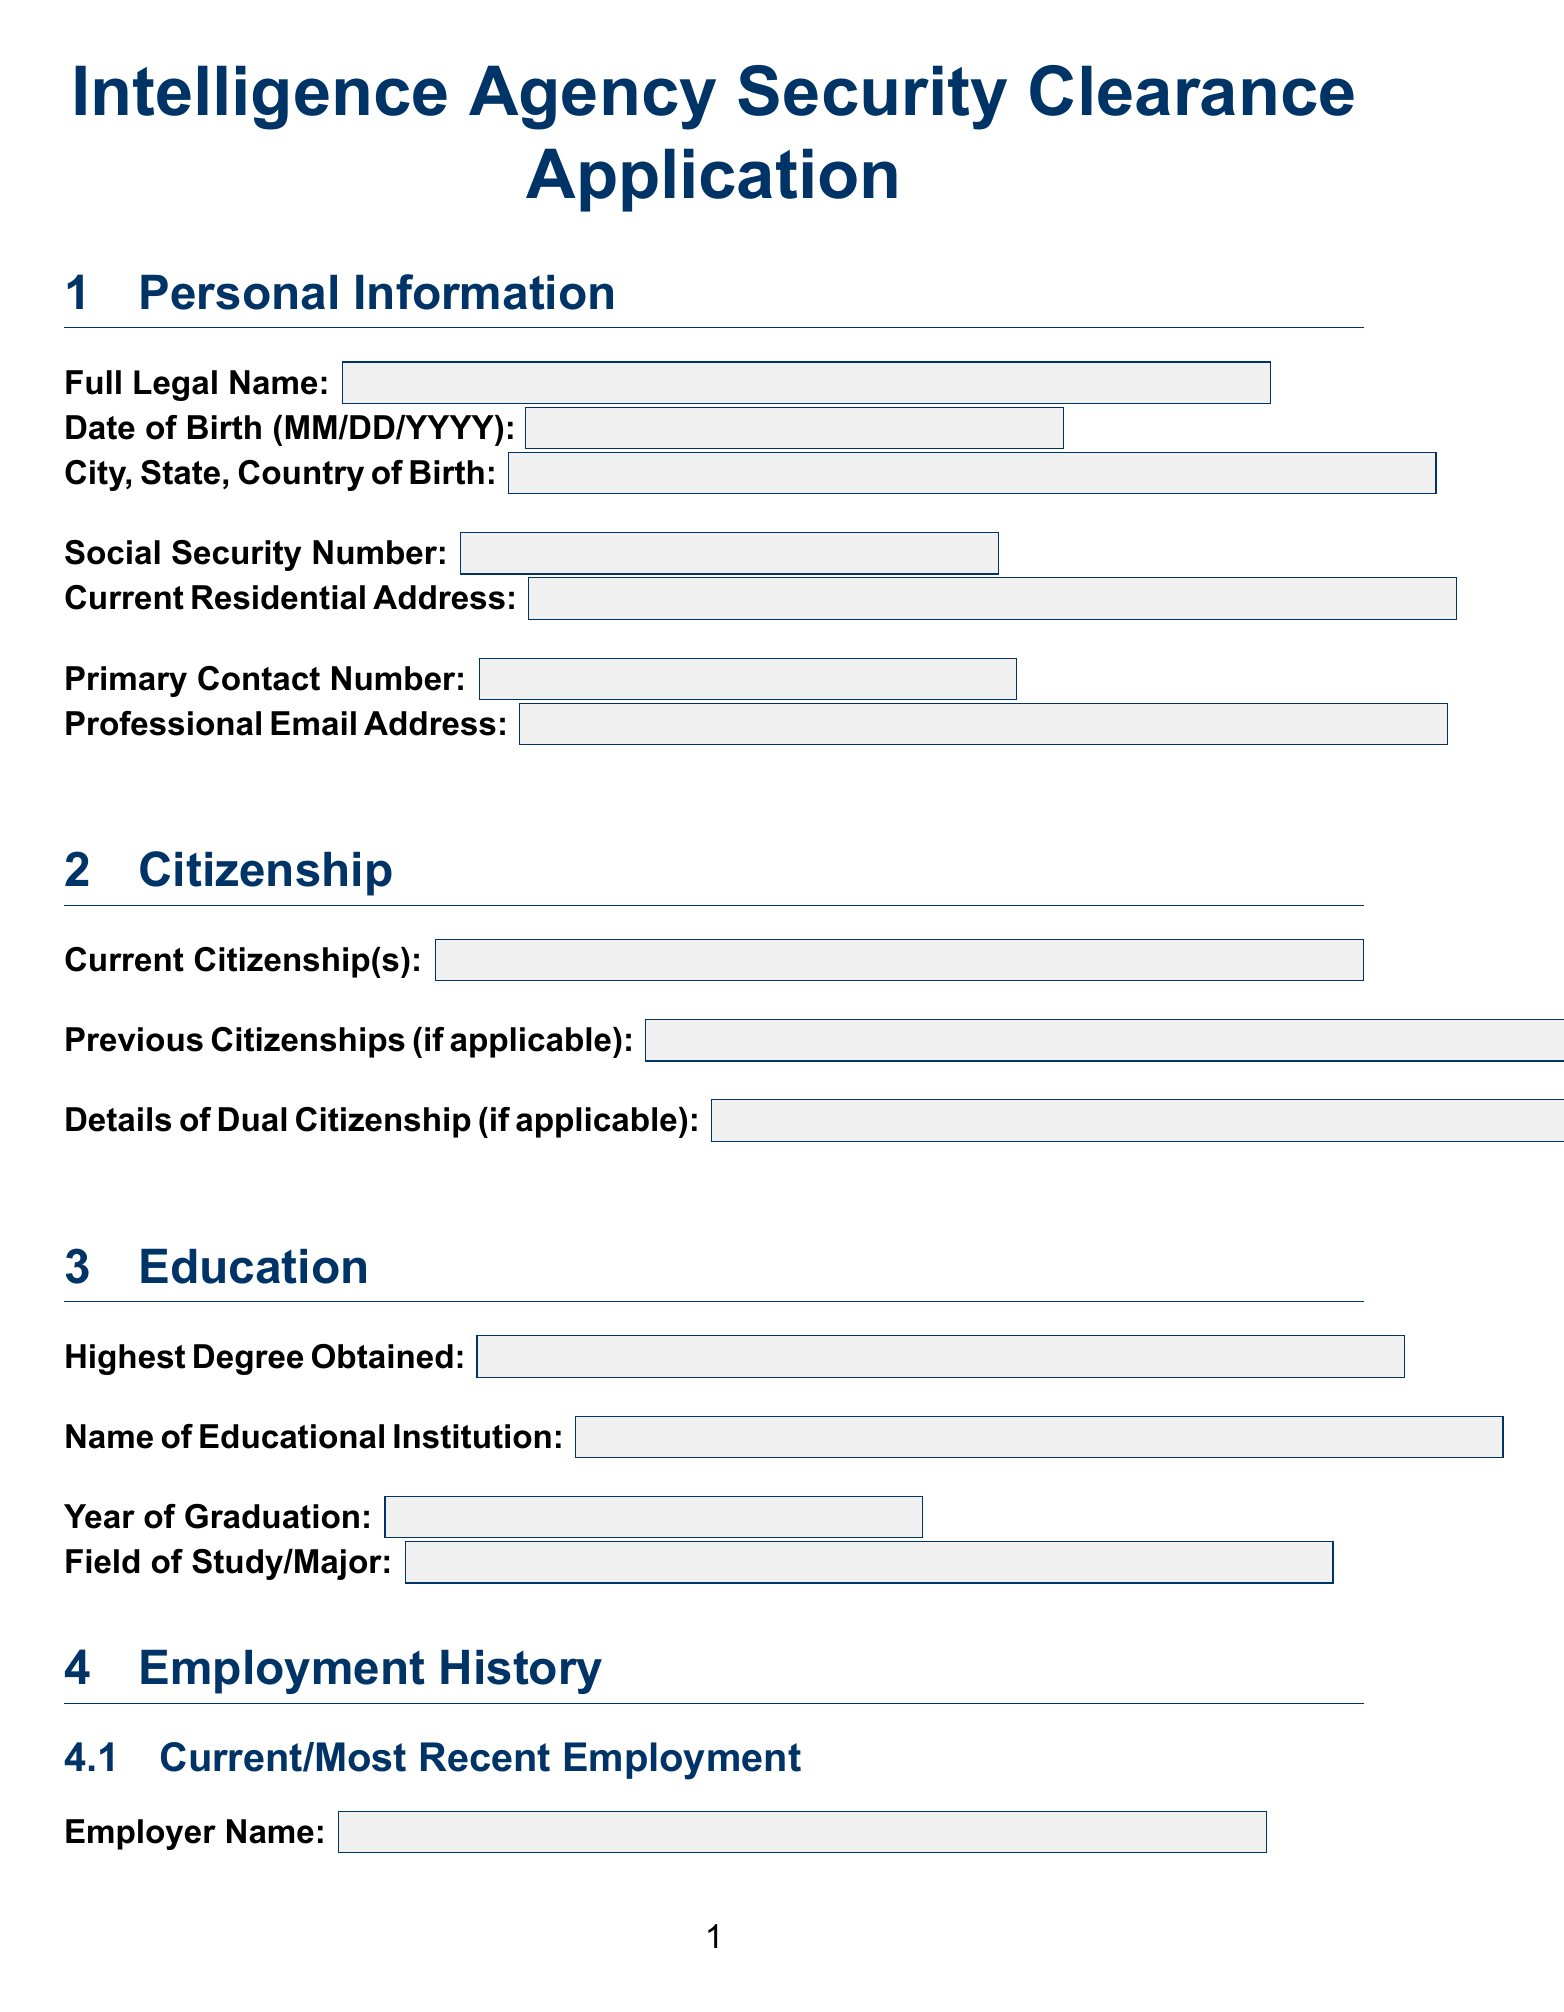What is the full legal name required on the application? The document specifies that the applicant needs to provide their full legal name in the personal information section.
Answer: Full Legal Name When was the date of birth expected to be provided? The date of birth is requested in the format MM/DD/YYYY in the personal information section of the form.
Answer: MM/DD/YYYY What is the highest degree obtained by the applicant? The document includes a section that asks for the highest degree obtained, indicating educational qualifications.
Answer: Highest Degree Obtained Who is the immediate supervisor for the current employer? The form requests the name of the immediate supervisor associated with the applicant's current employment.
Answer: Immediate Supervisor's Name List the training specific to professional background mentioned in the document. The document specifies different specialized training relevant to the applicant's professional background, which helps gauge preparedness.
Answer: Hostile Environment Awareness Training (HEAT), Digital Security for Journalists, Advanced Open-Source Intelligence (OSINT) Techniques How many languages should the applicant indicate proficiency in? The document prompts applicants to list the languages they speak along with the corresponding proficiency level, highlighting diversity in communication skills.
Answer: Language Name Does the applicant have any ongoing investigations related to government agencies? The document includes a security question that inquires about ongoing investigations involving government agencies or political figures, crucial for background checks.
Answer: Yes or No What is the consent given by the applicant for the background check? There is a declaration section that clarifies the applicant's consent to undergo a comprehensive background check as part of the security clearance process.
Answer: I consent to a comprehensive background check What are the references required in the document? The document includes a references section where the applicant must provide a full name, relationship, and contact information for their references.
Answer: Reference Full Name, Professional Relationship, Phone Number and Email 